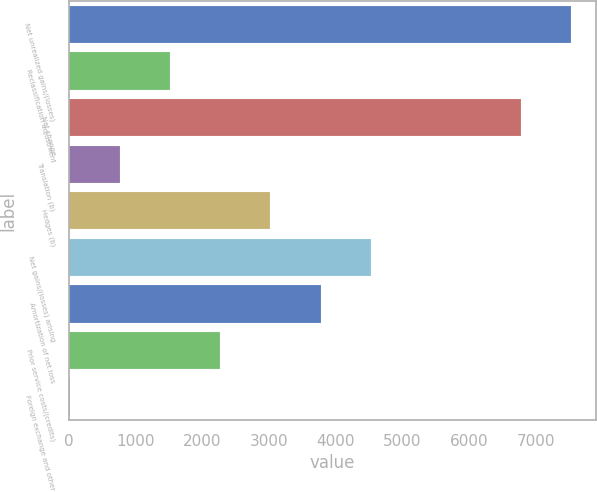Convert chart. <chart><loc_0><loc_0><loc_500><loc_500><bar_chart><fcel>Net unrealized gains/(losses)<fcel>Reclassification adjustment<fcel>Net change<fcel>Translation (b)<fcel>Hedges (b)<fcel>Net gains/(losses) arising<fcel>Amortization of net loss<fcel>Prior service costs/(credits)<fcel>Foreign exchange and other<nl><fcel>7521<fcel>1521<fcel>6771<fcel>771<fcel>3021<fcel>4521<fcel>3771<fcel>2271<fcel>21<nl></chart> 